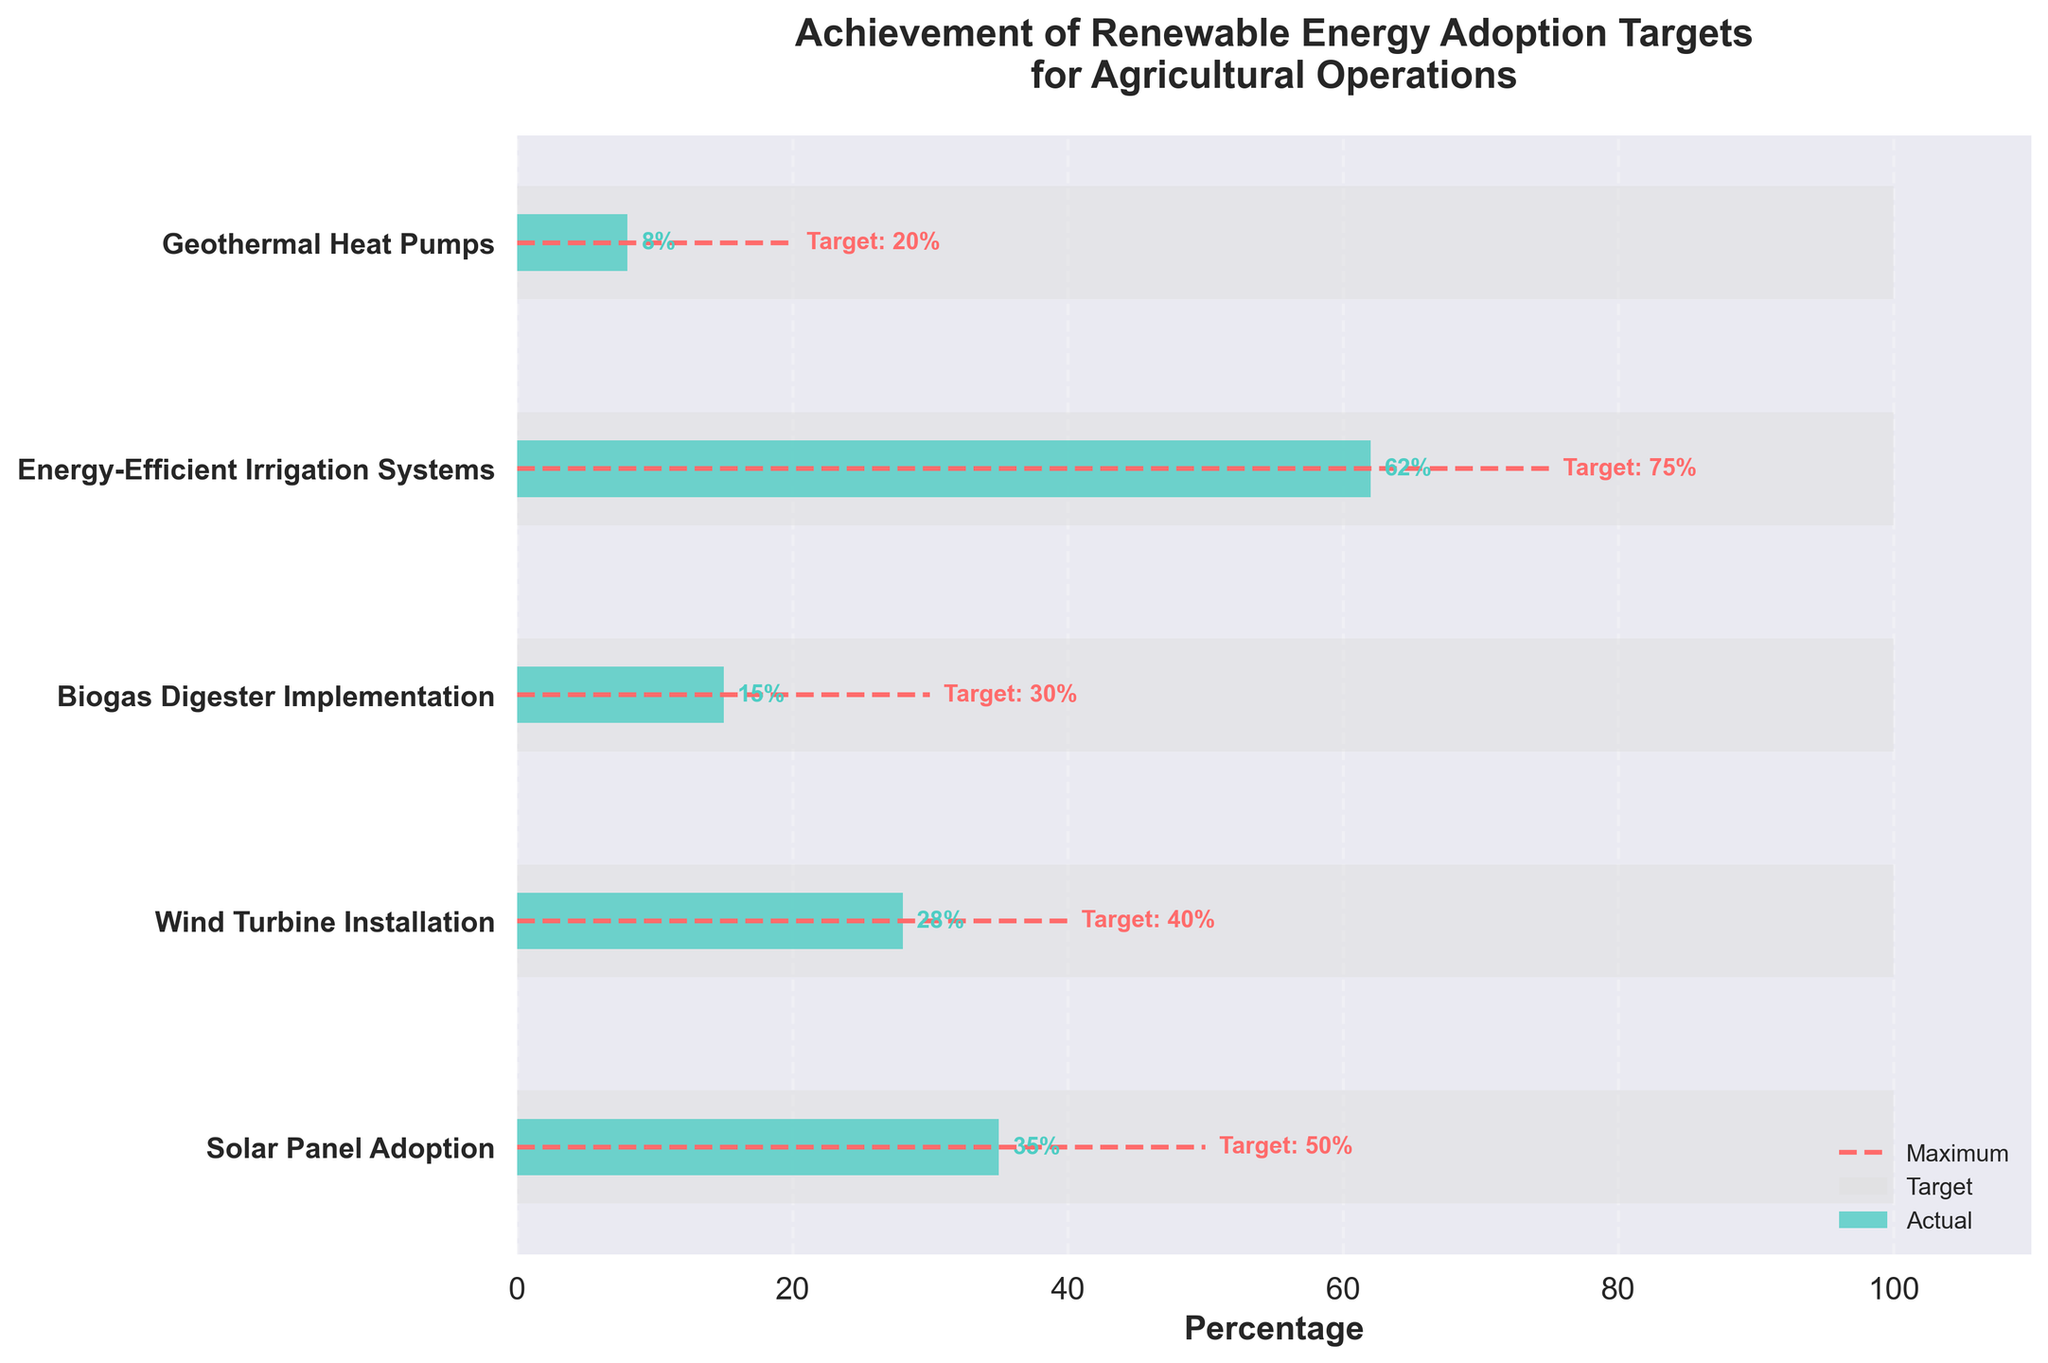Which renewable energy target has the highest percentage of actual achievement? According to the chart, Energy-Efficient Irrigation Systems have the highest actual achievement percentage. The actual value is 62%, which is the highest among all the categories.
Answer: Energy-Efficient Irrigation Systems What is the difference between the target and actual achievement for Wind Turbine Installation? To find the difference, subtract the actual percentage from the target percentage for Wind Turbine Installation. The target is 40% and the actual is 28%, so the difference is 40 - 28 = 12.
Answer: 12% Which category has the lowest actual achievement percentage? By examining the chart, we see that Geothermal Heat Pumps have the lowest actual achievement percentage at 8%.
Answer: Geothermal Heat Pumps How far is the actual achievement of Biogas Digester Implementation from the target? The actual achievement for Biogas Digester Implementation is 15%, and the target is 30%. The difference is 30 - 15 = 15%.
Answer: 15% What percentage of the target has been met for Solar Panel Adoption? Calculate the percentage of the target met for Solar Panel Adoption by (Actual / Target) * 100. The actual is 35 and the target is 50, so (35 / 50) * 100 = 70%.
Answer: 70% Among the listed categories, which one is closest to achieving its target? To find the category closest to its target, we compare the differences between actual and target values. Energy-Efficient Irrigation Systems have the smallest difference of 13% (75% - 62%), making it the closest.
Answer: Energy-Efficient Irrigation Systems For which categories is the actual achievement less than half of its target? Calculate and compare actual achievement with half of the target value for each category. For Wind Turbine Installation (28/2 < 40), Biogas Digester Implementation (15 < 30/2), and Geothermal Heat Pumps (8 < 20/2), actual values are less than half of the target.
Answer: Wind Turbine Installation, Biogas Digester Implementation, Geothermal Heat Pumps What is the average actual achievement percentage across all categories? Add up all actual percentages and divide by the number of categories: (35 + 28 + 15 + 62 + 8) / 5 = 148 / 5 = 29.6%.
Answer: 29.6% How much more needs to be achieved to meet the target for Biogas Digester Implementation? Subtract the actual value from the target for Biogas Digester Implementation. The target is 30% and the actual is 15%, resulting in 30 - 15 = 15%.
Answer: 15% Compare the achievements of the two least successful categories. Which one has a greater shortfall from its target? Compare the shortfall by subtracting actual values from targets: Geothermal Heat Pumps (20 - 8 = 12%) and Biogas Digester Implementation (30 - 15 = 15%). The latter has a greater shortfall.
Answer: Biogas Digester Implementation 